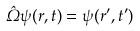<formula> <loc_0><loc_0><loc_500><loc_500>\hat { \Omega } \psi ( r , t ) = \psi ( r ^ { \prime } , t ^ { \prime } )</formula> 